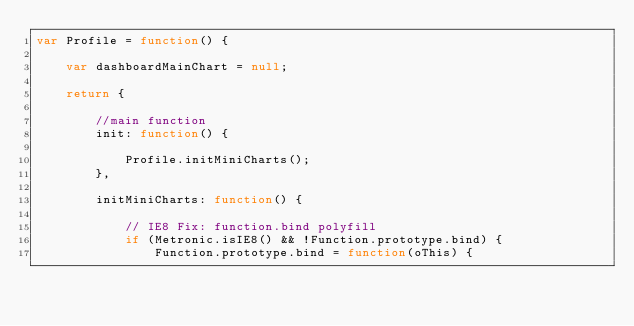<code> <loc_0><loc_0><loc_500><loc_500><_JavaScript_>var Profile = function() {

    var dashboardMainChart = null;

    return {

        //main function
        init: function() {
        
            Profile.initMiniCharts();
        },

        initMiniCharts: function() {

            // IE8 Fix: function.bind polyfill
            if (Metronic.isIE8() && !Function.prototype.bind) {
                Function.prototype.bind = function(oThis) {</code> 